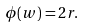<formula> <loc_0><loc_0><loc_500><loc_500>\phi ( w ) = 2 r .</formula> 